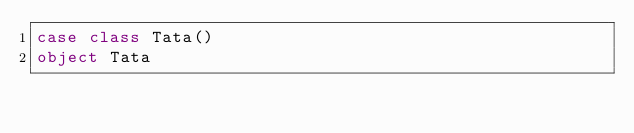<code> <loc_0><loc_0><loc_500><loc_500><_Scala_>case class Tata()
object Tata
</code> 